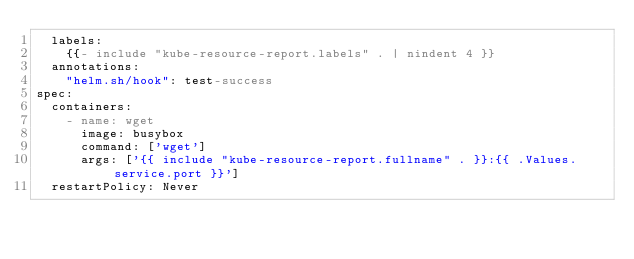Convert code to text. <code><loc_0><loc_0><loc_500><loc_500><_YAML_>  labels:
    {{- include "kube-resource-report.labels" . | nindent 4 }}
  annotations:
    "helm.sh/hook": test-success
spec:
  containers:
    - name: wget
      image: busybox
      command: ['wget']
      args: ['{{ include "kube-resource-report.fullname" . }}:{{ .Values.service.port }}']
  restartPolicy: Never
</code> 